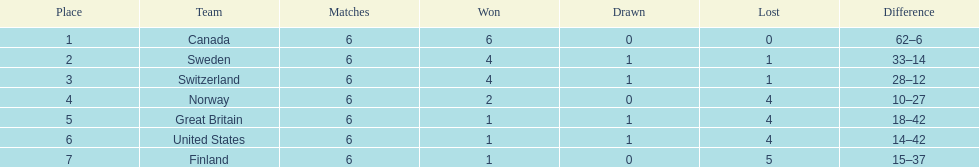What was the number of points won by great britain? 3. 